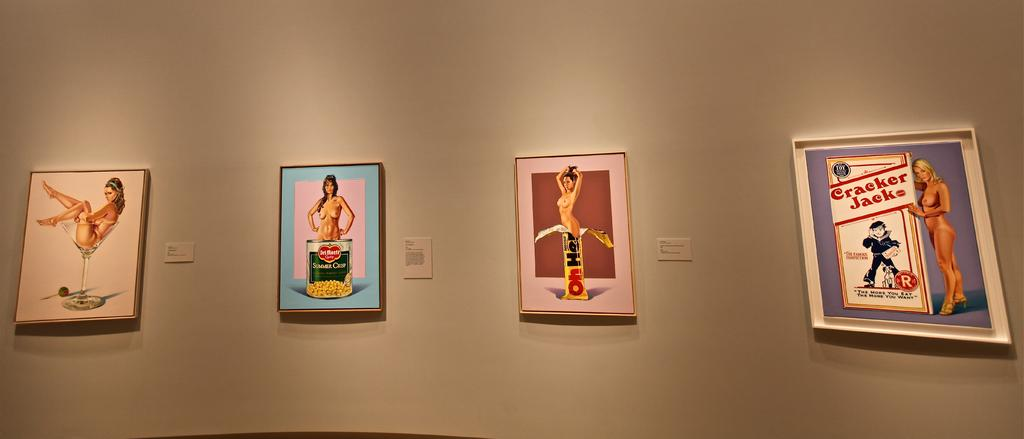<image>
Offer a succinct explanation of the picture presented. Pictures on a wall, the far right one says Cracker Jack. 